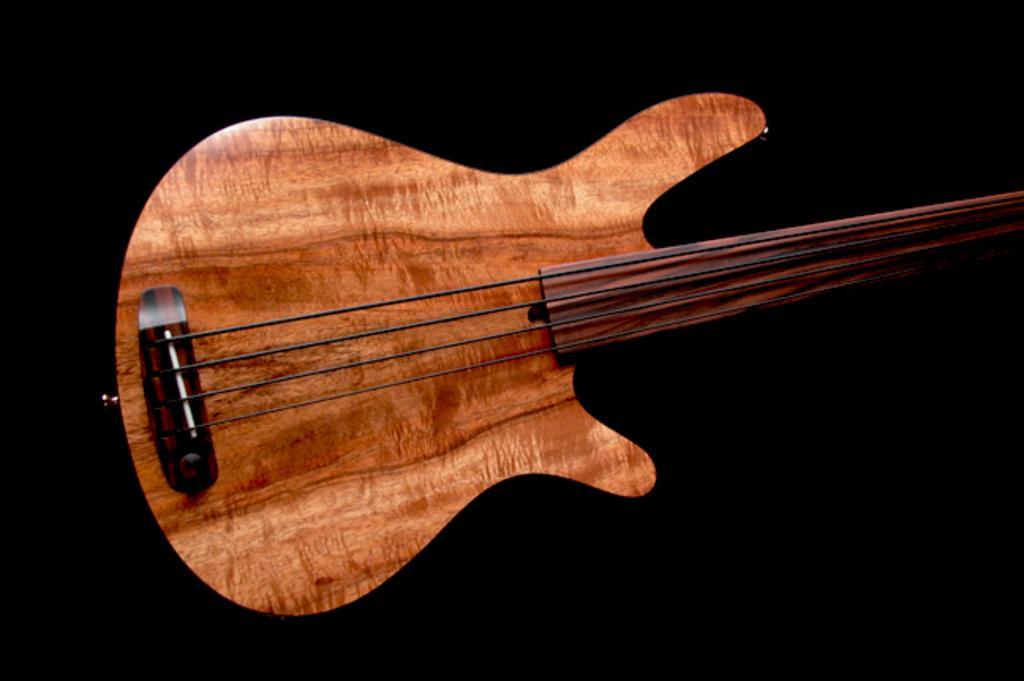How would you summarize this image in a sentence or two? The image consists of a wooden guitar with four strings the background is completely black. 